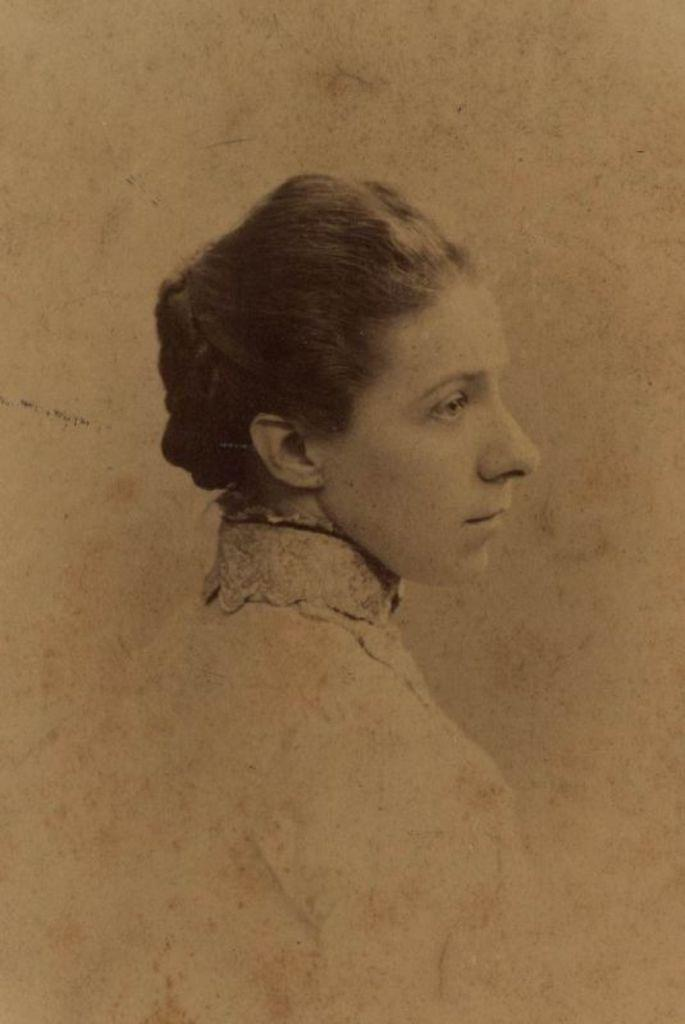What is the main subject of the image? There is a picture of a woman in the center of the image. What type of nerve is depicted in the image? There is no nerve depicted in the image; it features a picture of a woman. What design elements can be seen in the woman's clothing in the image? The provided facts do not mention any design elements in the woman's clothing, so we cannot answer this question definitively. 